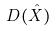<formula> <loc_0><loc_0><loc_500><loc_500>D ( \hat { X } )</formula> 